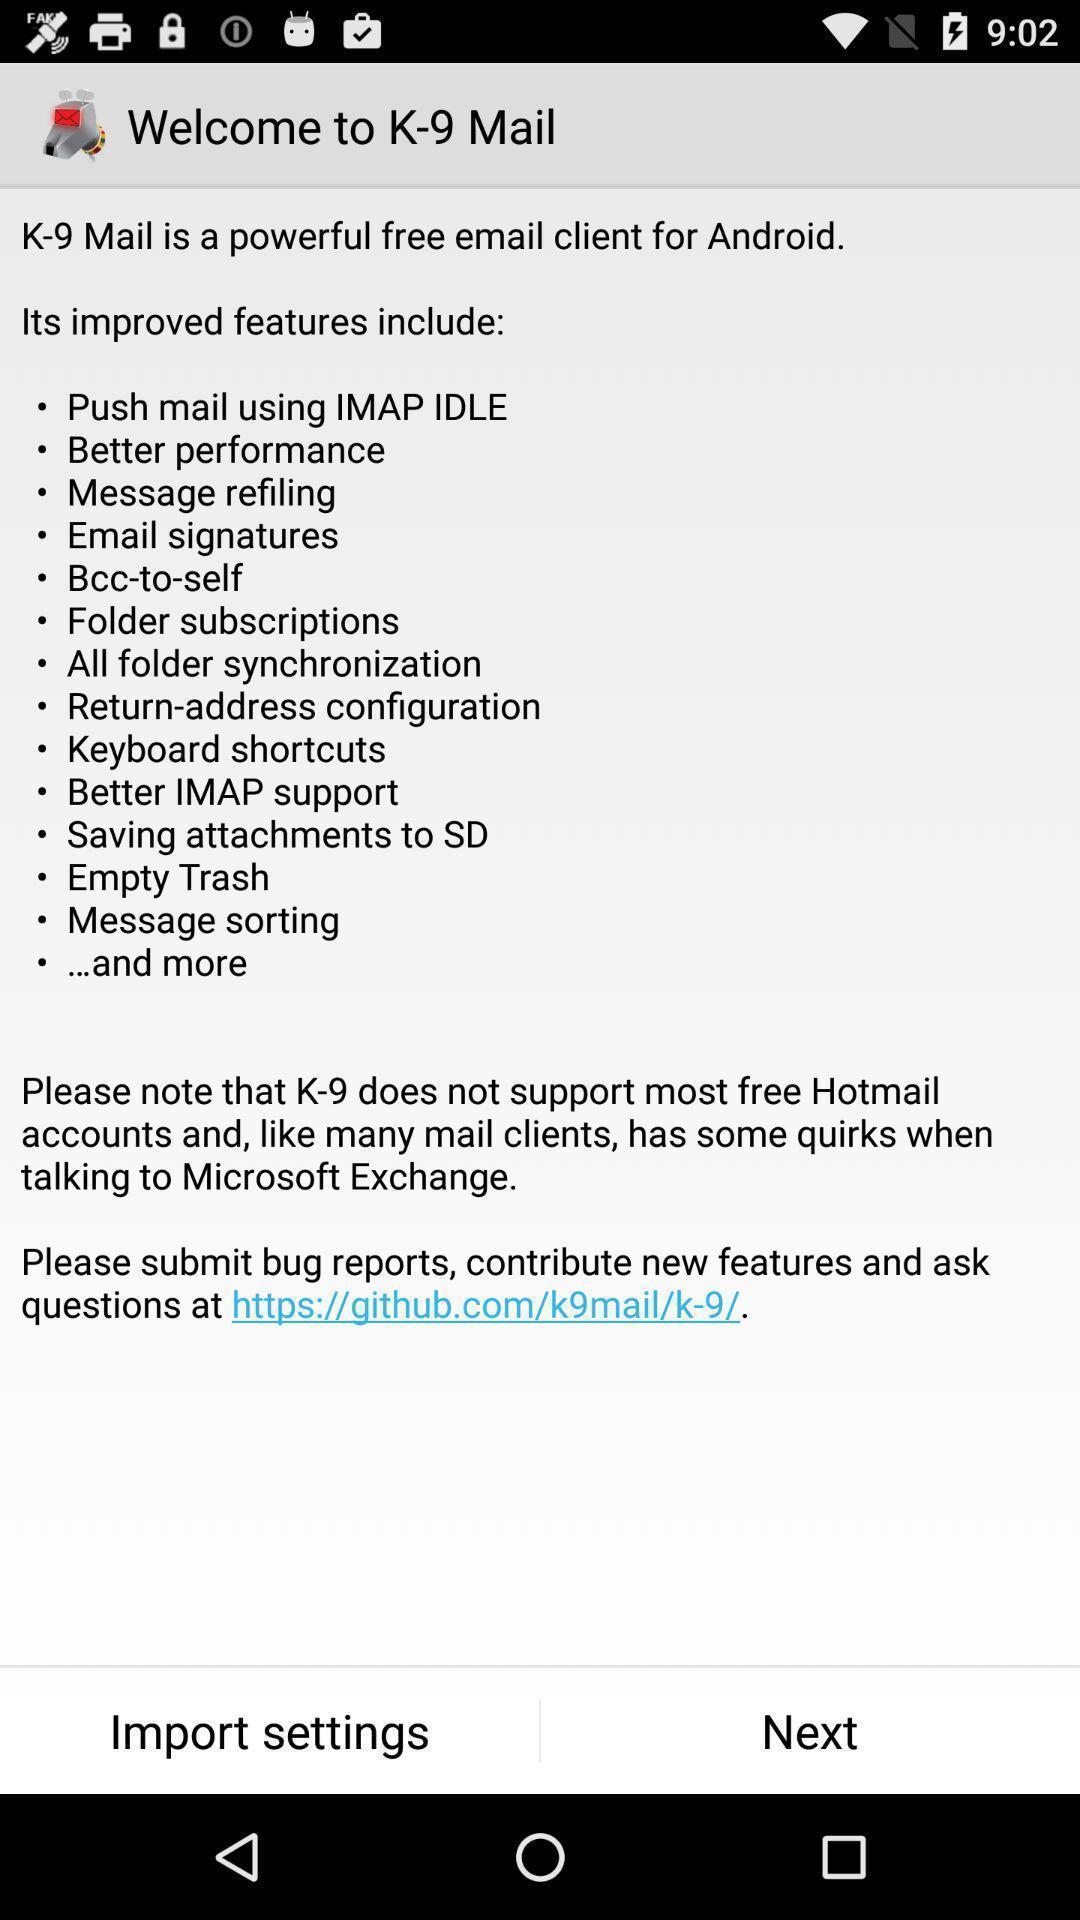Give me a summary of this screen capture. Welcome page with features include displayed. 